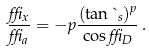Convert formula to latex. <formula><loc_0><loc_0><loc_500><loc_500>\frac { \delta _ { x } } { \delta _ { a } } = - p \frac { ( \tan \theta _ { s } ) ^ { p } } { \cos \delta _ { D } } \, .</formula> 